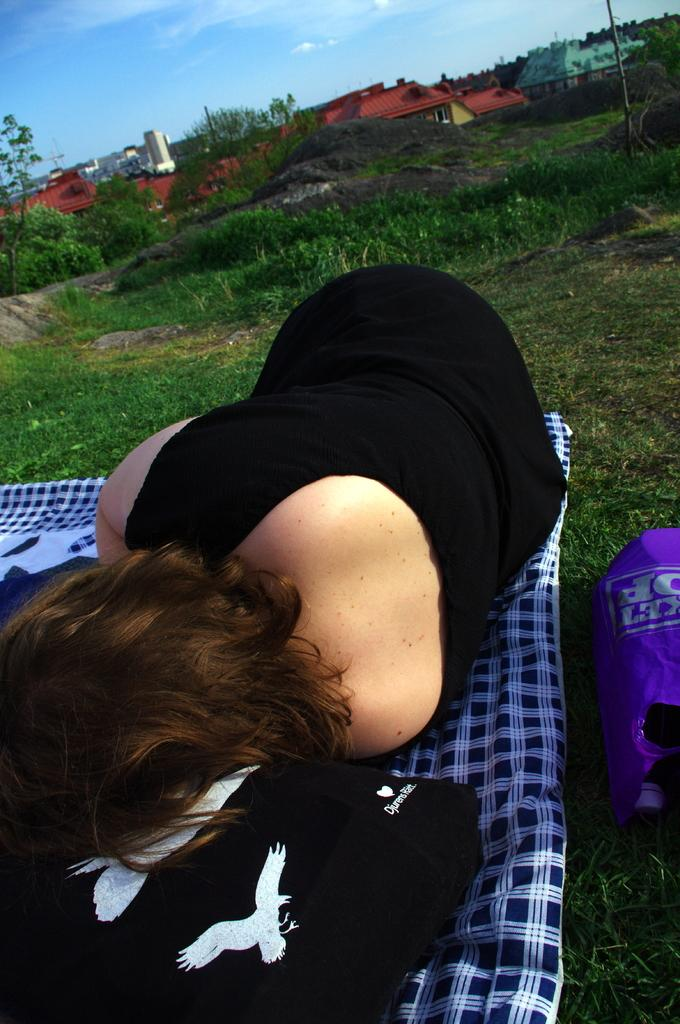Who is present in the image? There is a woman in the image. What is the woman wearing? The woman is wearing clothes. What is the woman doing in the image? The woman is lying down. What can be seen on the bed where the woman is lying? There is a bed sheet and a pillow in the image. What type of environment is visible in the image? There is grass, houses, trees, and the sky visible in the image. What type of base can be seen supporting the food in the image? There is no food or base present in the image. What kind of noise can be heard coming from the trees in the image? There is no sound or noise mentioned or depicted in the image. 